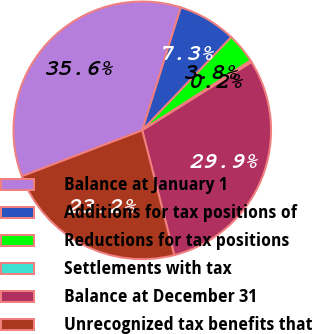<chart> <loc_0><loc_0><loc_500><loc_500><pie_chart><fcel>Balance at January 1<fcel>Additions for tax positions of<fcel>Reductions for tax positions<fcel>Settlements with tax<fcel>Balance at December 31<fcel>Unrecognized tax benefits that<nl><fcel>35.64%<fcel>7.3%<fcel>3.76%<fcel>0.22%<fcel>29.88%<fcel>23.19%<nl></chart> 